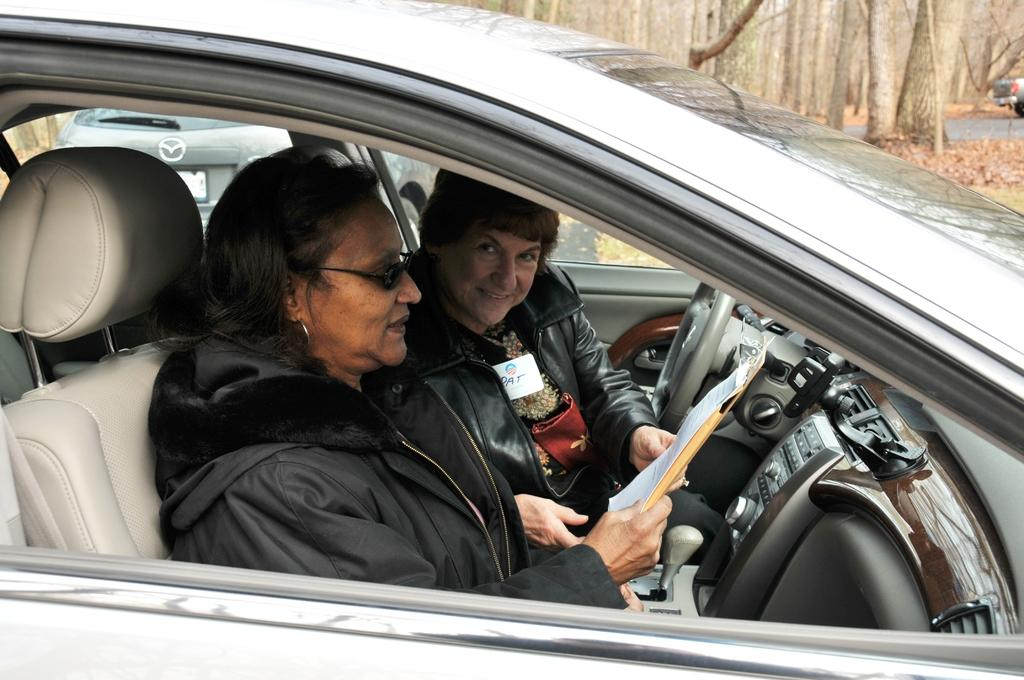How many women are in the image? There are two women in the image. What are the women wearing? The women are wearing black dresses. What are the women holding in the image? The women are holding a file. Where are the women located in the image? The women are sitting in a car. What type of animal can be seen sitting next to the women in the image? There are no animals present in the image; it only features two women sitting in a car. How did the women make their selection for the file they are holding? The image does not provide information about how the women made their selection for the file they are holding. 